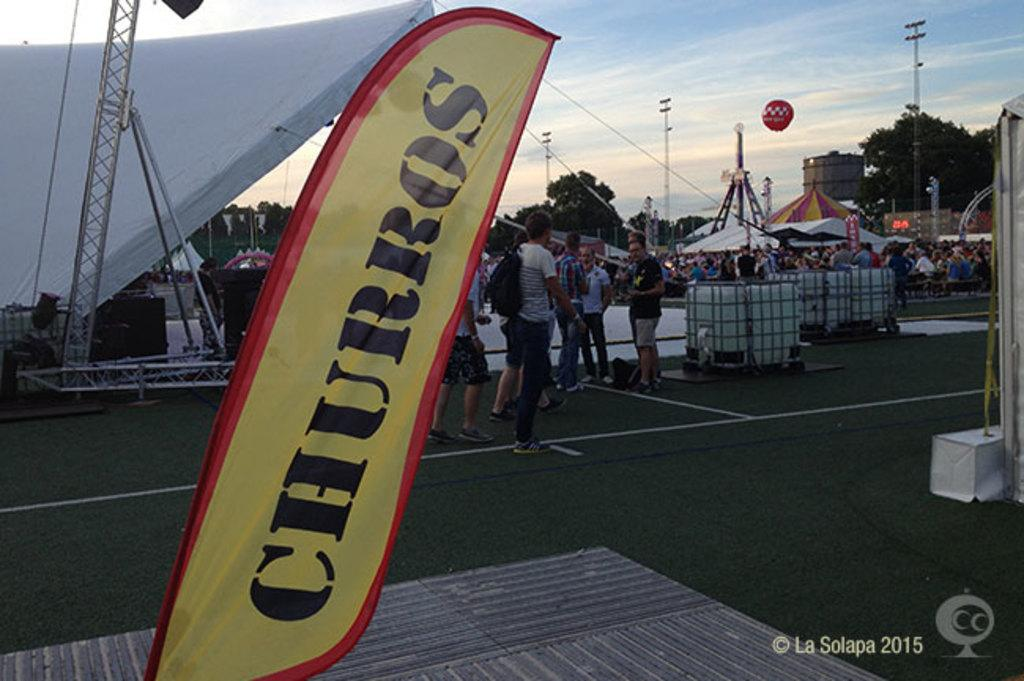<image>
Write a terse but informative summary of the picture. A yellow sign of Churros is in the foreground of a group of people at a carnival. 